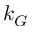<formula> <loc_0><loc_0><loc_500><loc_500>k _ { G }</formula> 